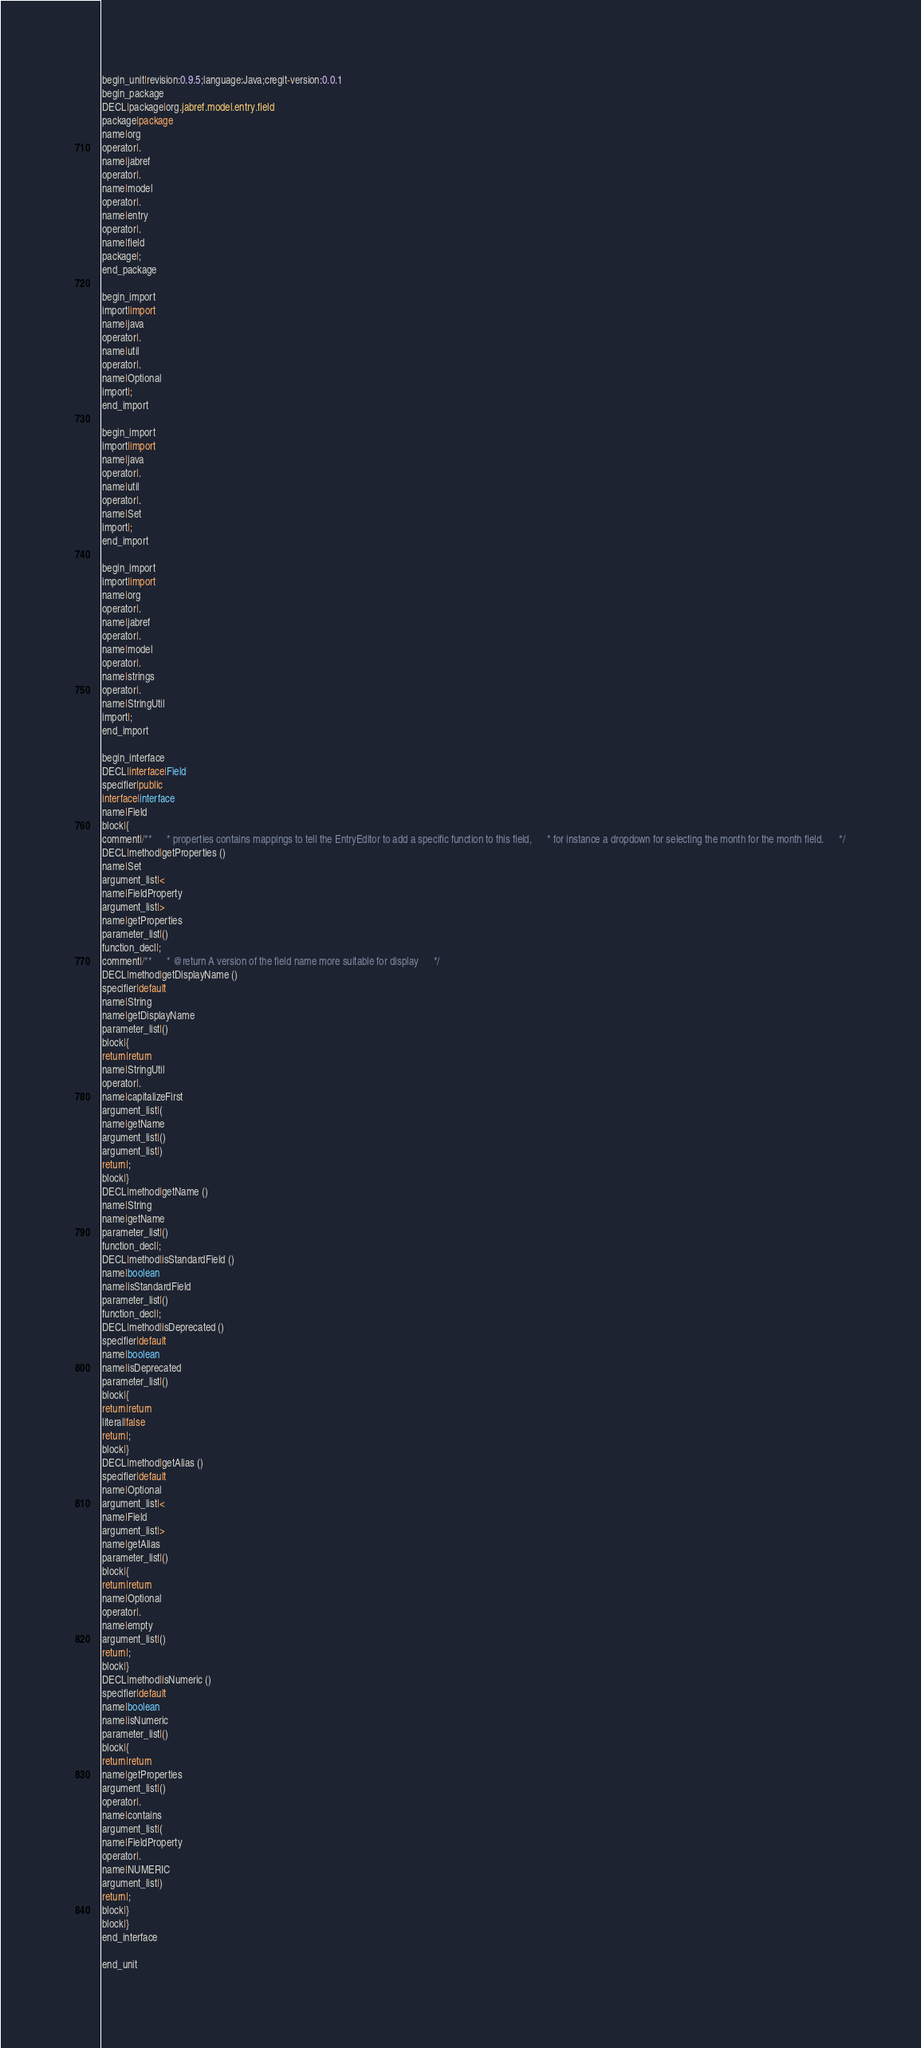Convert code to text. <code><loc_0><loc_0><loc_500><loc_500><_Java_>begin_unit|revision:0.9.5;language:Java;cregit-version:0.0.1
begin_package
DECL|package|org.jabref.model.entry.field
package|package
name|org
operator|.
name|jabref
operator|.
name|model
operator|.
name|entry
operator|.
name|field
package|;
end_package

begin_import
import|import
name|java
operator|.
name|util
operator|.
name|Optional
import|;
end_import

begin_import
import|import
name|java
operator|.
name|util
operator|.
name|Set
import|;
end_import

begin_import
import|import
name|org
operator|.
name|jabref
operator|.
name|model
operator|.
name|strings
operator|.
name|StringUtil
import|;
end_import

begin_interface
DECL|interface|Field
specifier|public
interface|interface
name|Field
block|{
comment|/**      * properties contains mappings to tell the EntryEditor to add a specific function to this field,      * for instance a dropdown for selecting the month for the month field.      */
DECL|method|getProperties ()
name|Set
argument_list|<
name|FieldProperty
argument_list|>
name|getProperties
parameter_list|()
function_decl|;
comment|/**      * @return A version of the field name more suitable for display      */
DECL|method|getDisplayName ()
specifier|default
name|String
name|getDisplayName
parameter_list|()
block|{
return|return
name|StringUtil
operator|.
name|capitalizeFirst
argument_list|(
name|getName
argument_list|()
argument_list|)
return|;
block|}
DECL|method|getName ()
name|String
name|getName
parameter_list|()
function_decl|;
DECL|method|isStandardField ()
name|boolean
name|isStandardField
parameter_list|()
function_decl|;
DECL|method|isDeprecated ()
specifier|default
name|boolean
name|isDeprecated
parameter_list|()
block|{
return|return
literal|false
return|;
block|}
DECL|method|getAlias ()
specifier|default
name|Optional
argument_list|<
name|Field
argument_list|>
name|getAlias
parameter_list|()
block|{
return|return
name|Optional
operator|.
name|empty
argument_list|()
return|;
block|}
DECL|method|isNumeric ()
specifier|default
name|boolean
name|isNumeric
parameter_list|()
block|{
return|return
name|getProperties
argument_list|()
operator|.
name|contains
argument_list|(
name|FieldProperty
operator|.
name|NUMERIC
argument_list|)
return|;
block|}
block|}
end_interface

end_unit

</code> 